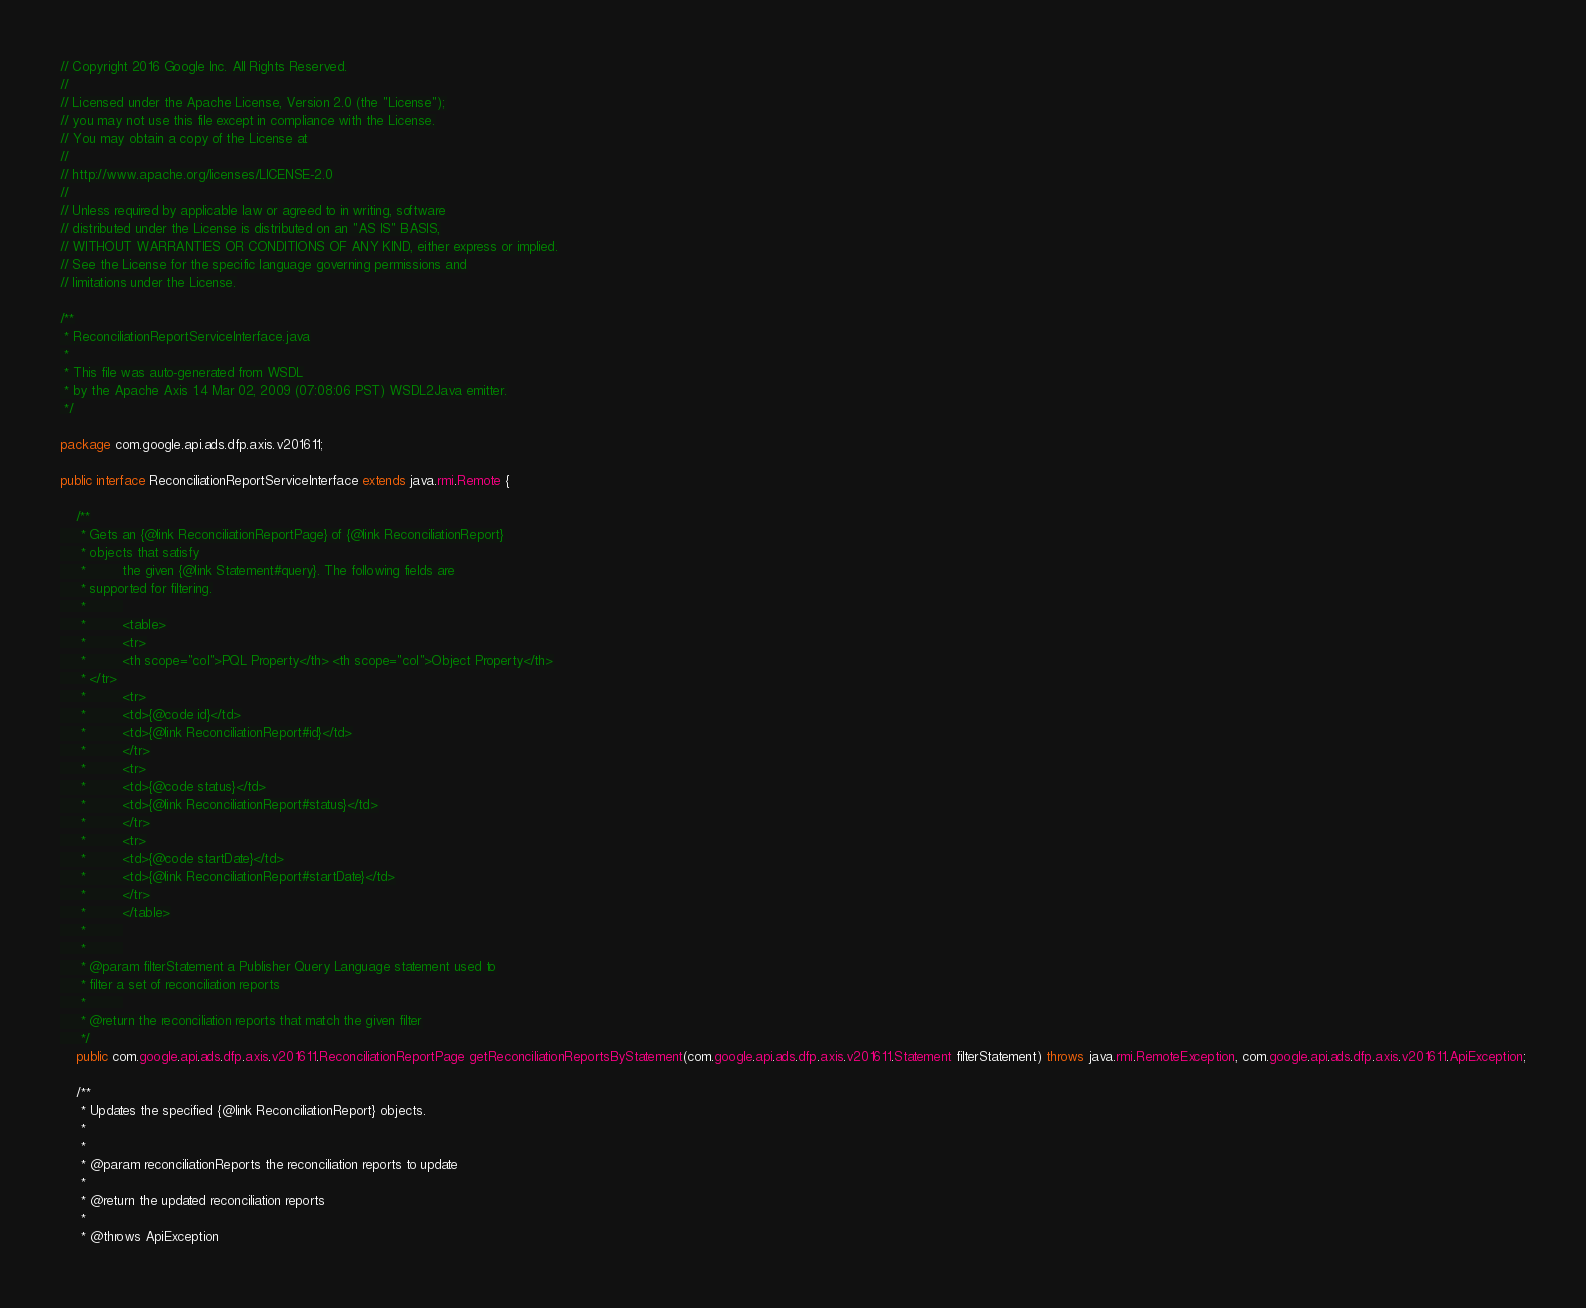<code> <loc_0><loc_0><loc_500><loc_500><_Java_>// Copyright 2016 Google Inc. All Rights Reserved.
//
// Licensed under the Apache License, Version 2.0 (the "License");
// you may not use this file except in compliance with the License.
// You may obtain a copy of the License at
//
// http://www.apache.org/licenses/LICENSE-2.0
//
// Unless required by applicable law or agreed to in writing, software
// distributed under the License is distributed on an "AS IS" BASIS,
// WITHOUT WARRANTIES OR CONDITIONS OF ANY KIND, either express or implied.
// See the License for the specific language governing permissions and
// limitations under the License.

/**
 * ReconciliationReportServiceInterface.java
 *
 * This file was auto-generated from WSDL
 * by the Apache Axis 1.4 Mar 02, 2009 (07:08:06 PST) WSDL2Java emitter.
 */

package com.google.api.ads.dfp.axis.v201611;

public interface ReconciliationReportServiceInterface extends java.rmi.Remote {

    /**
     * Gets an {@link ReconciliationReportPage} of {@link ReconciliationReport}
     * objects that satisfy
     *         the given {@link Statement#query}. The following fields are
     * supported for filtering.
     *         
     *         <table>
     *         <tr>
     *         <th scope="col">PQL Property</th> <th scope="col">Object Property</th>
     * </tr>
     *         <tr>
     *         <td>{@code id}</td>
     *         <td>{@link ReconciliationReport#id}</td>
     *         </tr>
     *         <tr>
     *         <td>{@code status}</td>
     *         <td>{@link ReconciliationReport#status}</td>
     *         </tr>
     *         <tr>
     *         <td>{@code startDate}</td>
     *         <td>{@link ReconciliationReport#startDate}</td>
     *         </tr>
     *         </table>
     *         
     *         
     * @param filterStatement a Publisher Query Language statement used to
     * filter a set of reconciliation reports
     *         
     * @return the reconciliation reports that match the given filter
     */
    public com.google.api.ads.dfp.axis.v201611.ReconciliationReportPage getReconciliationReportsByStatement(com.google.api.ads.dfp.axis.v201611.Statement filterStatement) throws java.rmi.RemoteException, com.google.api.ads.dfp.axis.v201611.ApiException;

    /**
     * Updates the specified {@link ReconciliationReport} objects.
     * 
     *         
     * @param reconciliationReports the reconciliation reports to update
     *         
     * @return the updated reconciliation reports
     *         
     * @throws ApiException</code> 